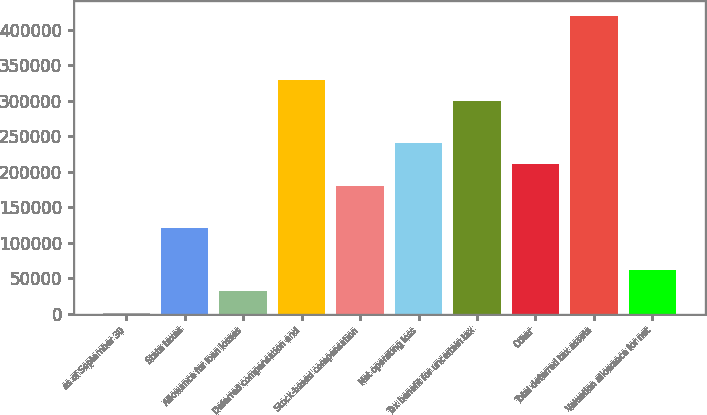Convert chart. <chart><loc_0><loc_0><loc_500><loc_500><bar_chart><fcel>as of September 30<fcel>State taxes<fcel>Allowance for loan losses<fcel>Deferred compensation and<fcel>Stock-based compensation<fcel>Net operating loss<fcel>Tax benefit for uncertain tax<fcel>Other<fcel>Total deferred tax assets<fcel>Valuation allowance for net<nl><fcel>2010<fcel>121055<fcel>31771.2<fcel>329383<fcel>180577<fcel>240100<fcel>299622<fcel>210338<fcel>418667<fcel>61532.4<nl></chart> 